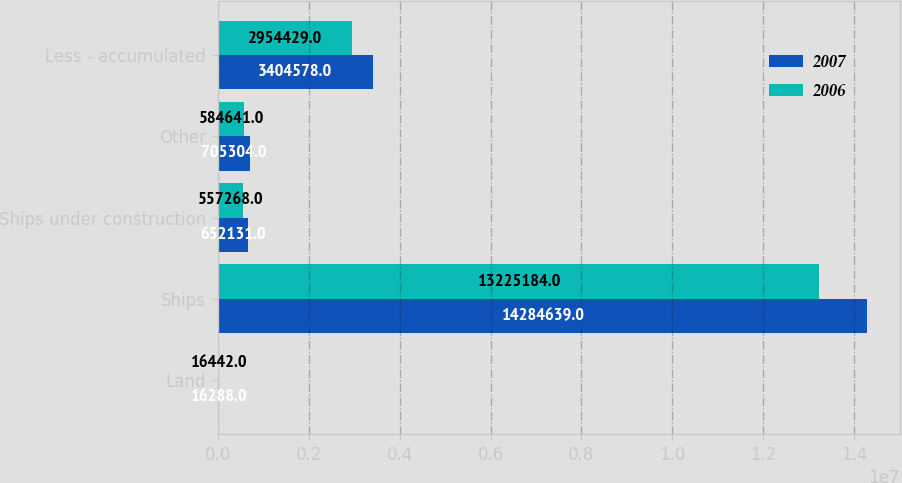Convert chart to OTSL. <chart><loc_0><loc_0><loc_500><loc_500><stacked_bar_chart><ecel><fcel>Land<fcel>Ships<fcel>Ships under construction<fcel>Other<fcel>Less - accumulated<nl><fcel>2007<fcel>16288<fcel>1.42846e+07<fcel>652131<fcel>705304<fcel>3.40458e+06<nl><fcel>2006<fcel>16442<fcel>1.32252e+07<fcel>557268<fcel>584641<fcel>2.95443e+06<nl></chart> 